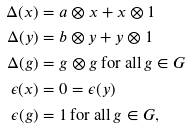<formula> <loc_0><loc_0><loc_500><loc_500>\Delta ( x ) & = a \otimes x + x \otimes 1 \\ \Delta ( y ) & = b \otimes y + y \otimes 1 \\ \Delta ( g ) & = g \otimes g \, \text {for all} \, g \in G \\ \epsilon ( x ) & = 0 = \epsilon ( y ) \\ \epsilon ( g ) & = 1 \, \text {for all} \, g \in G ,</formula> 